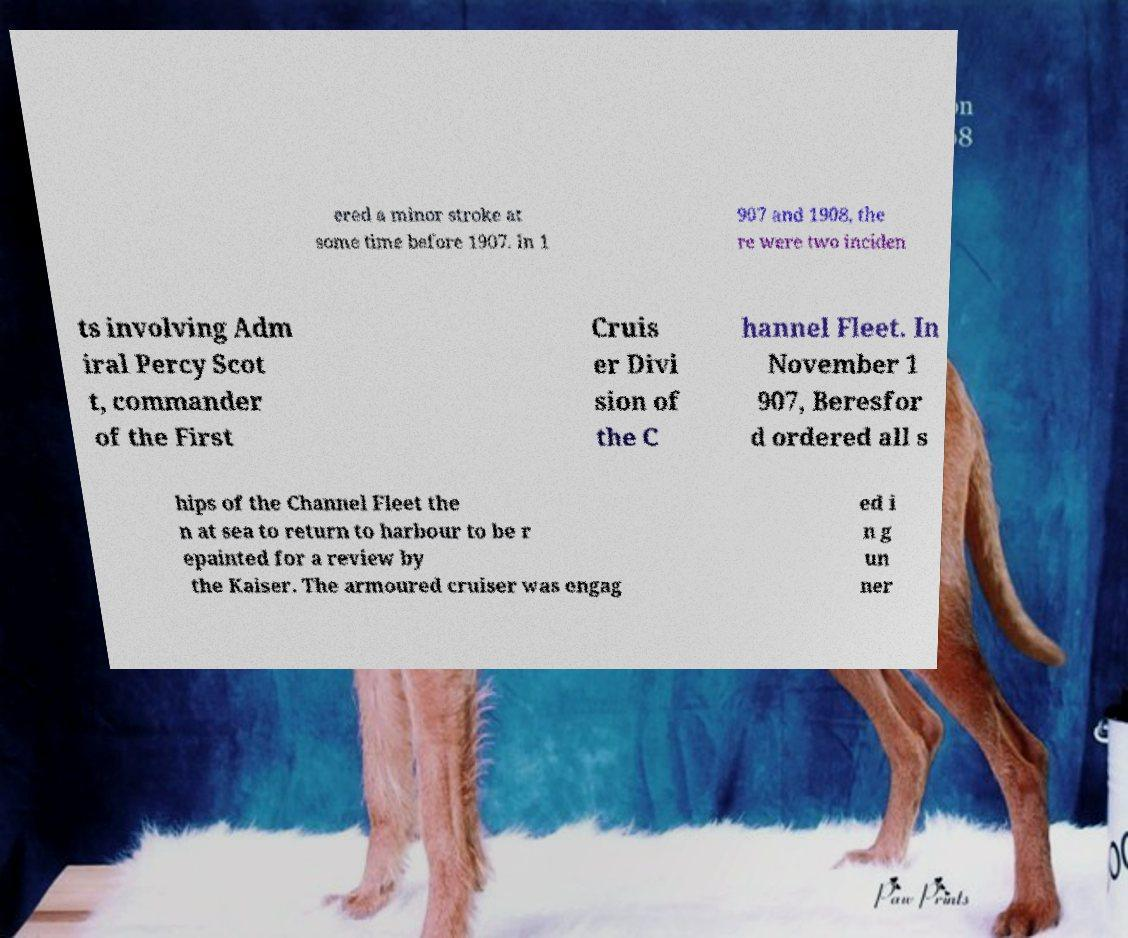Please identify and transcribe the text found in this image. ered a minor stroke at some time before 1907. In 1 907 and 1908, the re were two inciden ts involving Adm iral Percy Scot t, commander of the First Cruis er Divi sion of the C hannel Fleet. In November 1 907, Beresfor d ordered all s hips of the Channel Fleet the n at sea to return to harbour to be r epainted for a review by the Kaiser. The armoured cruiser was engag ed i n g un ner 